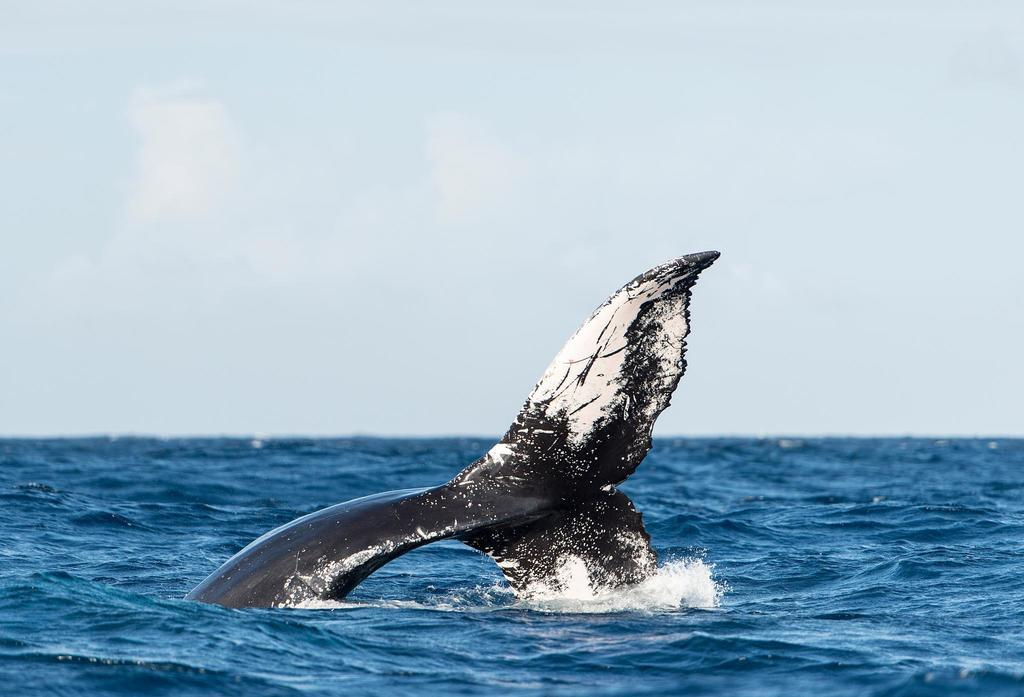What is in the water in the image? There is a whale in the water. What is the condition of the sky in the image? The sky is cloudy. What type of scarf is being used to comfort the whale during the discussion in the image? There is no scarf, comforting, or discussion present in the image; it features a whale in the water and a cloudy sky. 